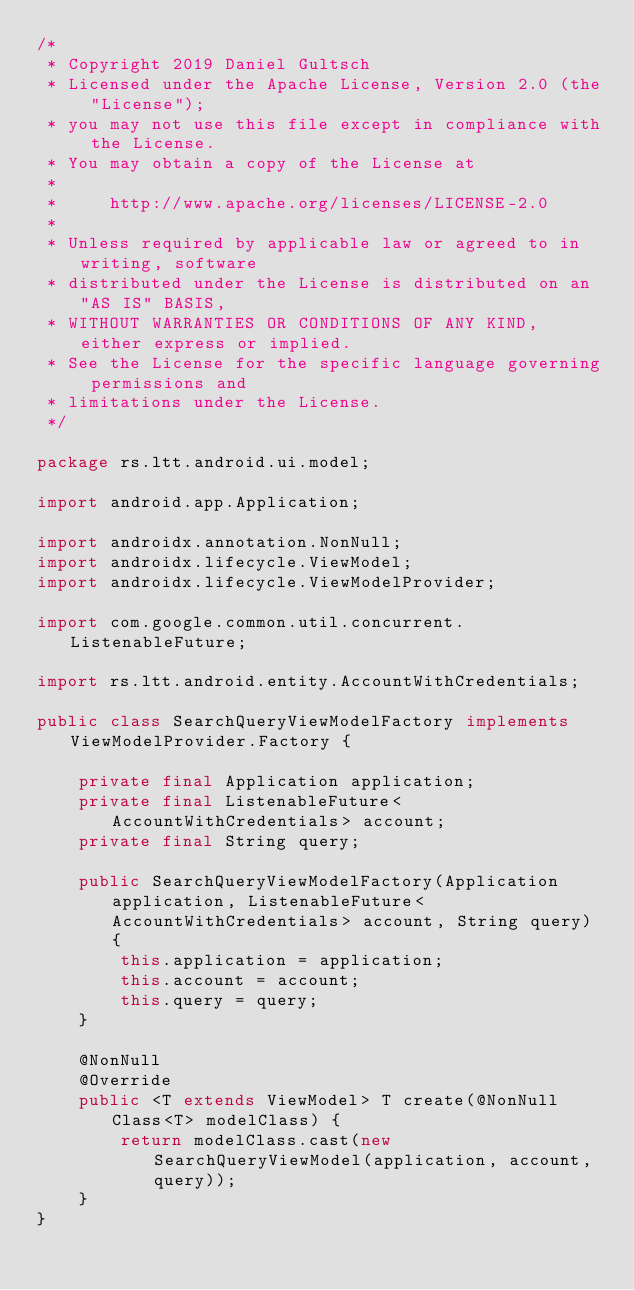Convert code to text. <code><loc_0><loc_0><loc_500><loc_500><_Java_>/*
 * Copyright 2019 Daniel Gultsch
 * Licensed under the Apache License, Version 2.0 (the "License");
 * you may not use this file except in compliance with the License.
 * You may obtain a copy of the License at
 *
 *     http://www.apache.org/licenses/LICENSE-2.0
 *
 * Unless required by applicable law or agreed to in writing, software
 * distributed under the License is distributed on an "AS IS" BASIS,
 * WITHOUT WARRANTIES OR CONDITIONS OF ANY KIND, either express or implied.
 * See the License for the specific language governing permissions and
 * limitations under the License.
 */

package rs.ltt.android.ui.model;

import android.app.Application;

import androidx.annotation.NonNull;
import androidx.lifecycle.ViewModel;
import androidx.lifecycle.ViewModelProvider;

import com.google.common.util.concurrent.ListenableFuture;

import rs.ltt.android.entity.AccountWithCredentials;

public class SearchQueryViewModelFactory implements ViewModelProvider.Factory {

    private final Application application;
    private final ListenableFuture<AccountWithCredentials> account;
    private final String query;

    public SearchQueryViewModelFactory(Application application, ListenableFuture<AccountWithCredentials> account, String query) {
        this.application = application;
        this.account = account;
        this.query = query;
    }

    @NonNull
    @Override
    public <T extends ViewModel> T create(@NonNull Class<T> modelClass) {
        return modelClass.cast(new SearchQueryViewModel(application, account, query));
    }
}
</code> 